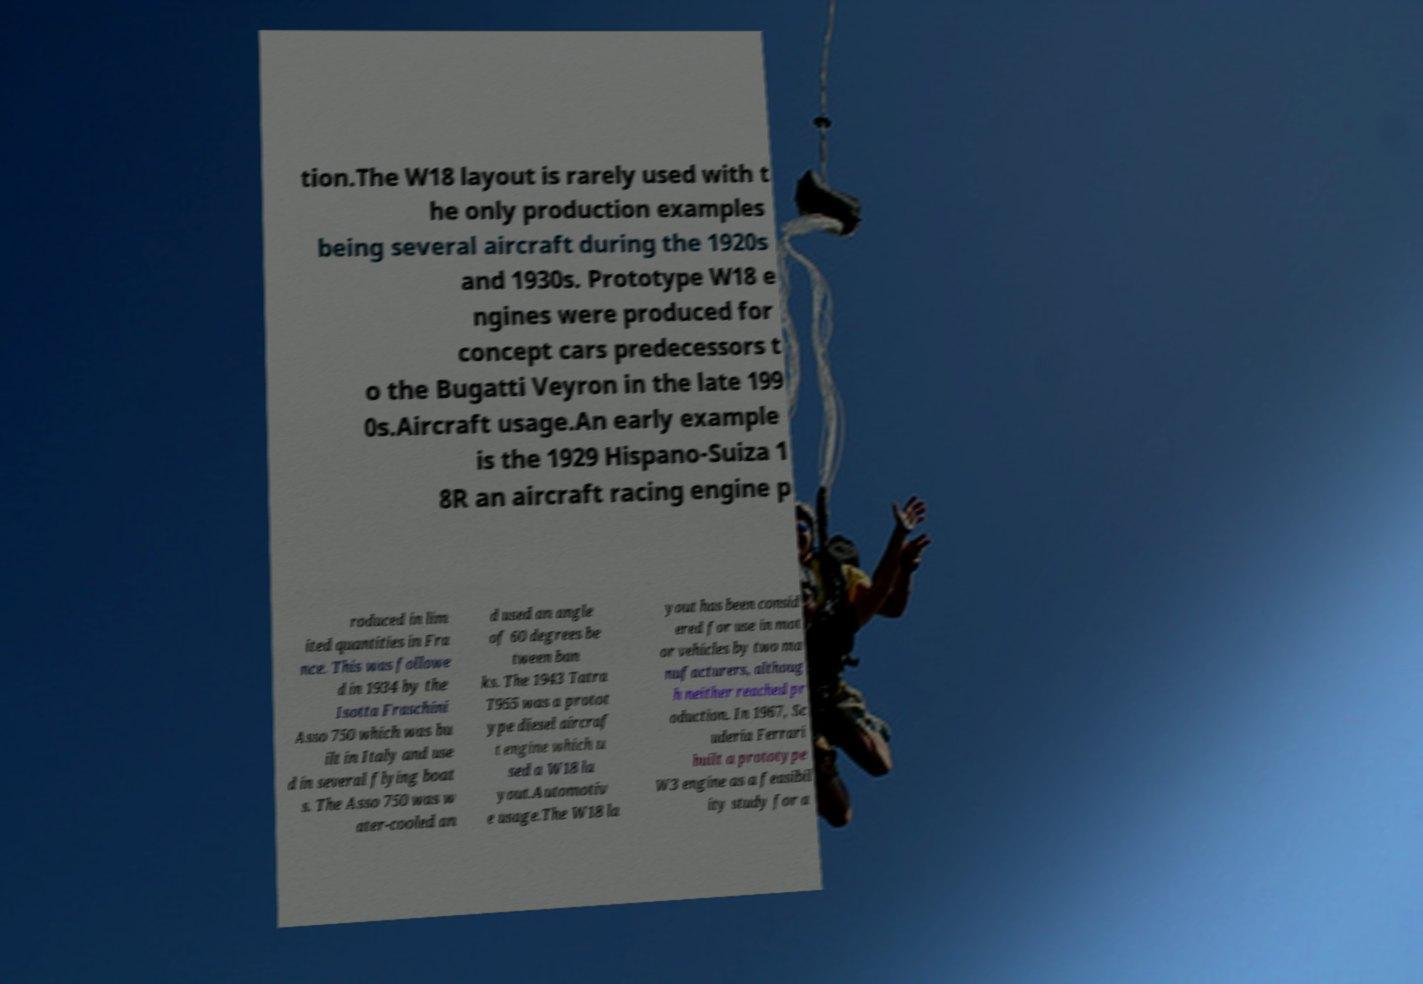Please read and relay the text visible in this image. What does it say? tion.The W18 layout is rarely used with t he only production examples being several aircraft during the 1920s and 1930s. Prototype W18 e ngines were produced for concept cars predecessors t o the Bugatti Veyron in the late 199 0s.Aircraft usage.An early example is the 1929 Hispano-Suiza 1 8R an aircraft racing engine p roduced in lim ited quantities in Fra nce. This was followe d in 1934 by the Isotta Fraschini Asso 750 which was bu ilt in Italy and use d in several flying boat s. The Asso 750 was w ater-cooled an d used an angle of 60 degrees be tween ban ks. The 1943 Tatra T955 was a protot ype diesel aircraf t engine which u sed a W18 la yout.Automotiv e usage.The W18 la yout has been consid ered for use in mot or vehicles by two ma nufacturers, althoug h neither reached pr oduction. In 1967, Sc uderia Ferrari built a prototype W3 engine as a feasibil ity study for a 